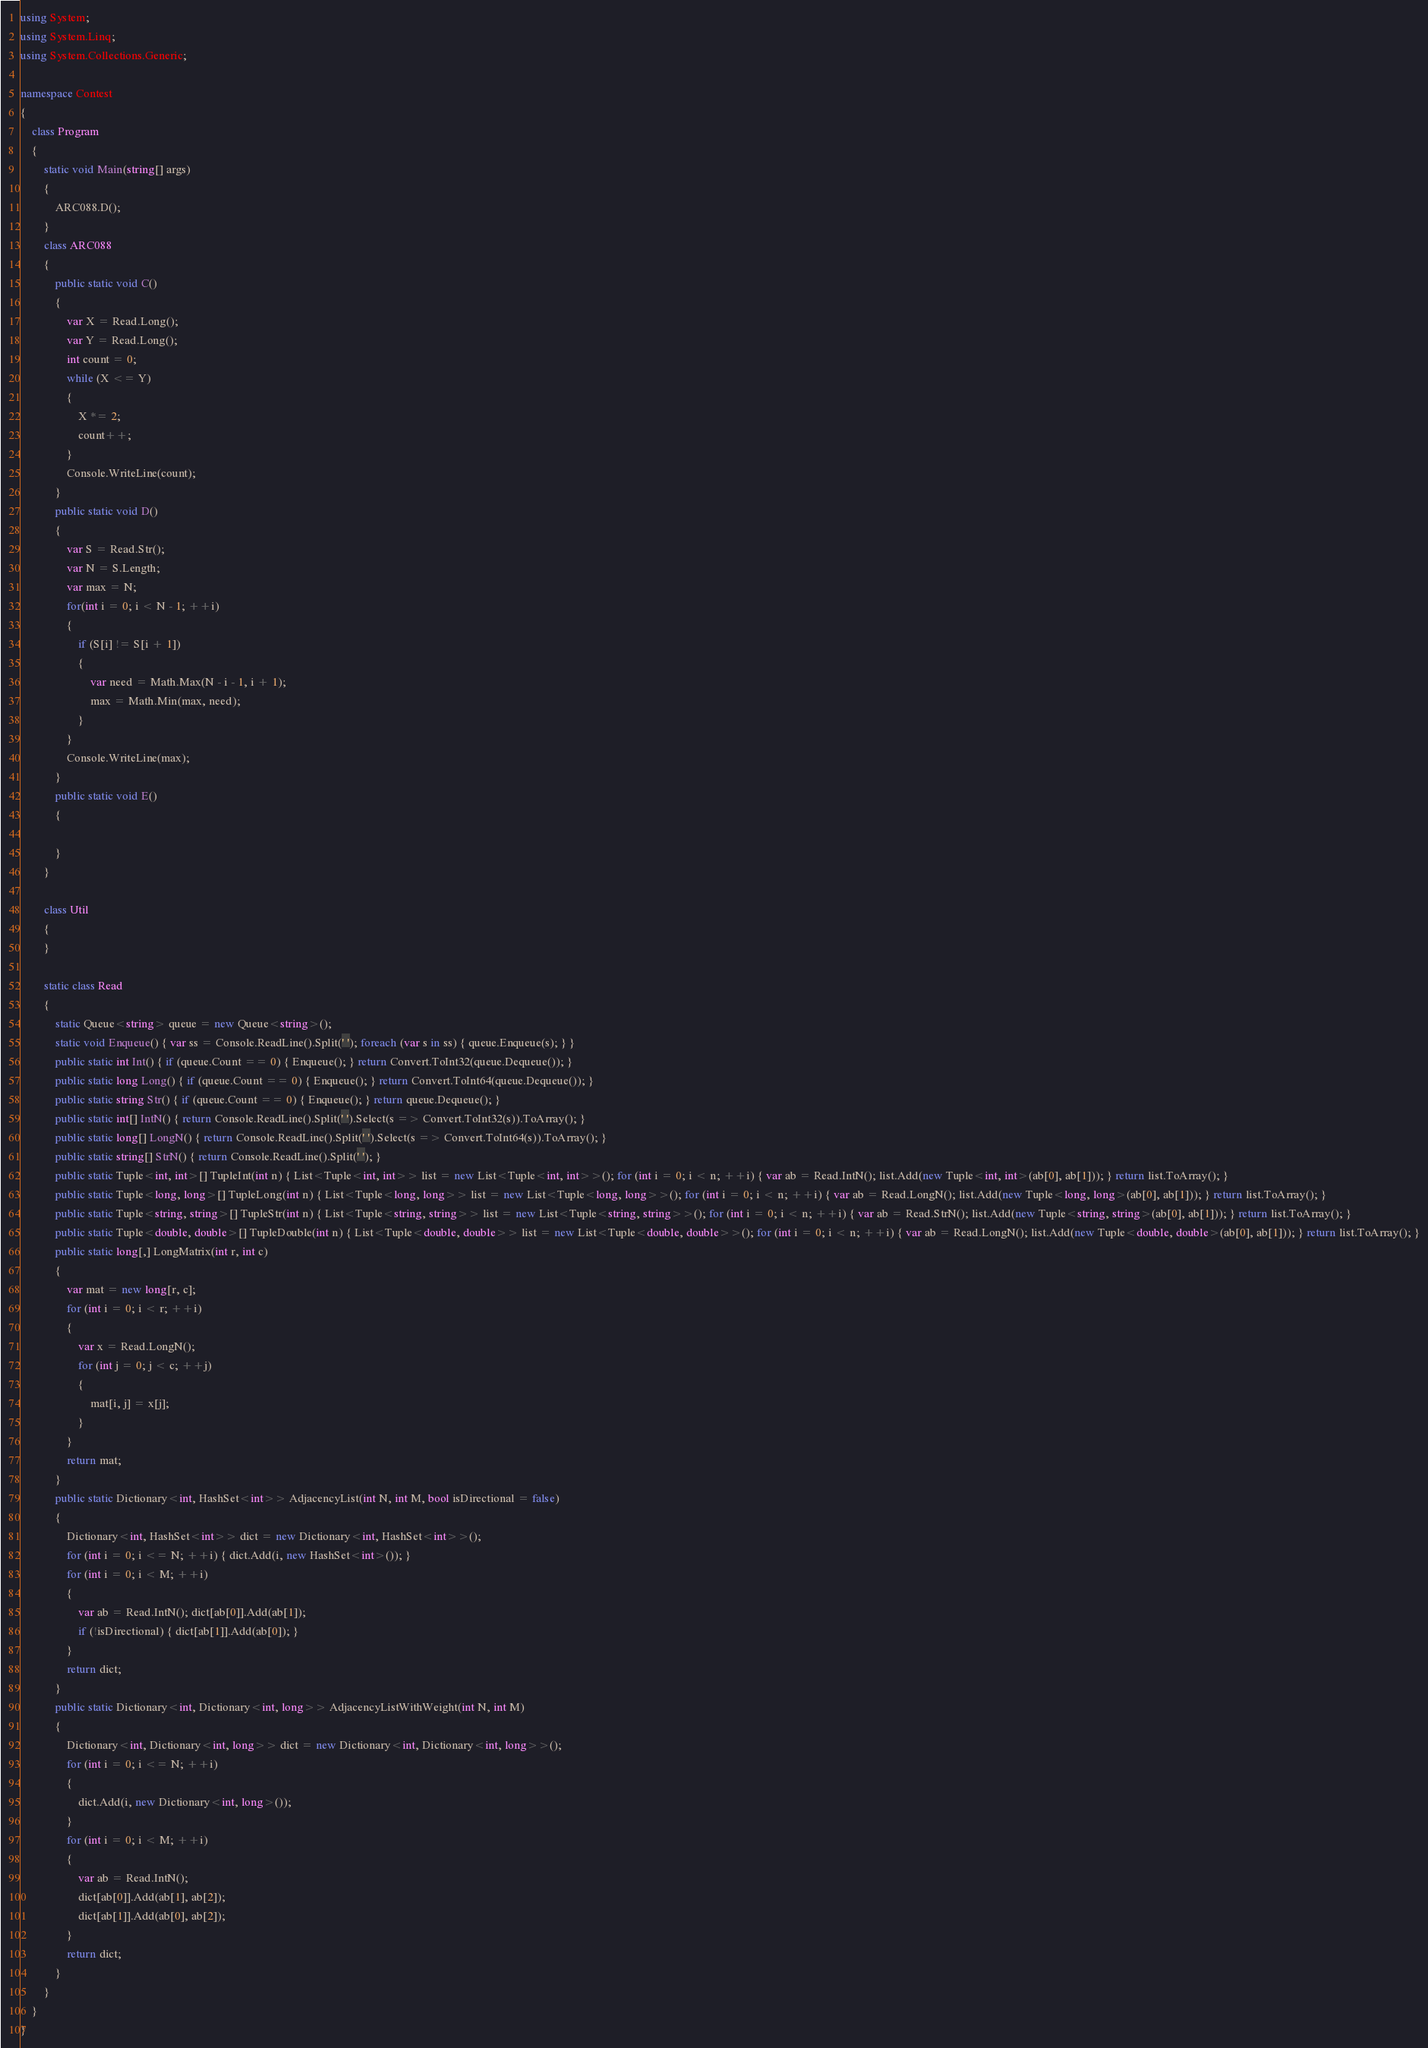Convert code to text. <code><loc_0><loc_0><loc_500><loc_500><_C#_>using System;
using System.Linq;
using System.Collections.Generic;

namespace Contest
{
    class Program
    {
        static void Main(string[] args)
        {
            ARC088.D();
        }
        class ARC088
        {
            public static void C()
            {
                var X = Read.Long();
                var Y = Read.Long();
                int count = 0;
                while (X <= Y)
                {
                    X *= 2;
                    count++;
                }
                Console.WriteLine(count);
            }
            public static void D()
            {
                var S = Read.Str();
                var N = S.Length;
                var max = N;
                for(int i = 0; i < N - 1; ++i)
                {
                    if (S[i] != S[i + 1])
                    {
                        var need = Math.Max(N - i - 1, i + 1);
                        max = Math.Min(max, need);
                    }
                }
                Console.WriteLine(max);
            }
            public static void E()
            {

            }
        }

        class Util
        {
        }

        static class Read
        {
            static Queue<string> queue = new Queue<string>();
            static void Enqueue() { var ss = Console.ReadLine().Split(' '); foreach (var s in ss) { queue.Enqueue(s); } }
            public static int Int() { if (queue.Count == 0) { Enqueue(); } return Convert.ToInt32(queue.Dequeue()); }
            public static long Long() { if (queue.Count == 0) { Enqueue(); } return Convert.ToInt64(queue.Dequeue()); }
            public static string Str() { if (queue.Count == 0) { Enqueue(); } return queue.Dequeue(); }
            public static int[] IntN() { return Console.ReadLine().Split(' ').Select(s => Convert.ToInt32(s)).ToArray(); }
            public static long[] LongN() { return Console.ReadLine().Split(' ').Select(s => Convert.ToInt64(s)).ToArray(); }
            public static string[] StrN() { return Console.ReadLine().Split(' '); }
            public static Tuple<int, int>[] TupleInt(int n) { List<Tuple<int, int>> list = new List<Tuple<int, int>>(); for (int i = 0; i < n; ++i) { var ab = Read.IntN(); list.Add(new Tuple<int, int>(ab[0], ab[1])); } return list.ToArray(); }
            public static Tuple<long, long>[] TupleLong(int n) { List<Tuple<long, long>> list = new List<Tuple<long, long>>(); for (int i = 0; i < n; ++i) { var ab = Read.LongN(); list.Add(new Tuple<long, long>(ab[0], ab[1])); } return list.ToArray(); }
            public static Tuple<string, string>[] TupleStr(int n) { List<Tuple<string, string>> list = new List<Tuple<string, string>>(); for (int i = 0; i < n; ++i) { var ab = Read.StrN(); list.Add(new Tuple<string, string>(ab[0], ab[1])); } return list.ToArray(); }
            public static Tuple<double, double>[] TupleDouble(int n) { List<Tuple<double, double>> list = new List<Tuple<double, double>>(); for (int i = 0; i < n; ++i) { var ab = Read.LongN(); list.Add(new Tuple<double, double>(ab[0], ab[1])); } return list.ToArray(); }
            public static long[,] LongMatrix(int r, int c)
            {
                var mat = new long[r, c];
                for (int i = 0; i < r; ++i)
                {
                    var x = Read.LongN();
                    for (int j = 0; j < c; ++j)
                    {
                        mat[i, j] = x[j];
                    }
                }
                return mat;
            }
            public static Dictionary<int, HashSet<int>> AdjacencyList(int N, int M, bool isDirectional = false)
            {
                Dictionary<int, HashSet<int>> dict = new Dictionary<int, HashSet<int>>();
                for (int i = 0; i <= N; ++i) { dict.Add(i, new HashSet<int>()); }
                for (int i = 0; i < M; ++i)
                {
                    var ab = Read.IntN(); dict[ab[0]].Add(ab[1]);
                    if (!isDirectional) { dict[ab[1]].Add(ab[0]); }
                }
                return dict;
            }
            public static Dictionary<int, Dictionary<int, long>> AdjacencyListWithWeight(int N, int M)
            {
                Dictionary<int, Dictionary<int, long>> dict = new Dictionary<int, Dictionary<int, long>>();
                for (int i = 0; i <= N; ++i)
                {
                    dict.Add(i, new Dictionary<int, long>());
                }
                for (int i = 0; i < M; ++i)
                {
                    var ab = Read.IntN();
                    dict[ab[0]].Add(ab[1], ab[2]);
                    dict[ab[1]].Add(ab[0], ab[2]);
                }
                return dict;
            }
        }
    }
}
</code> 